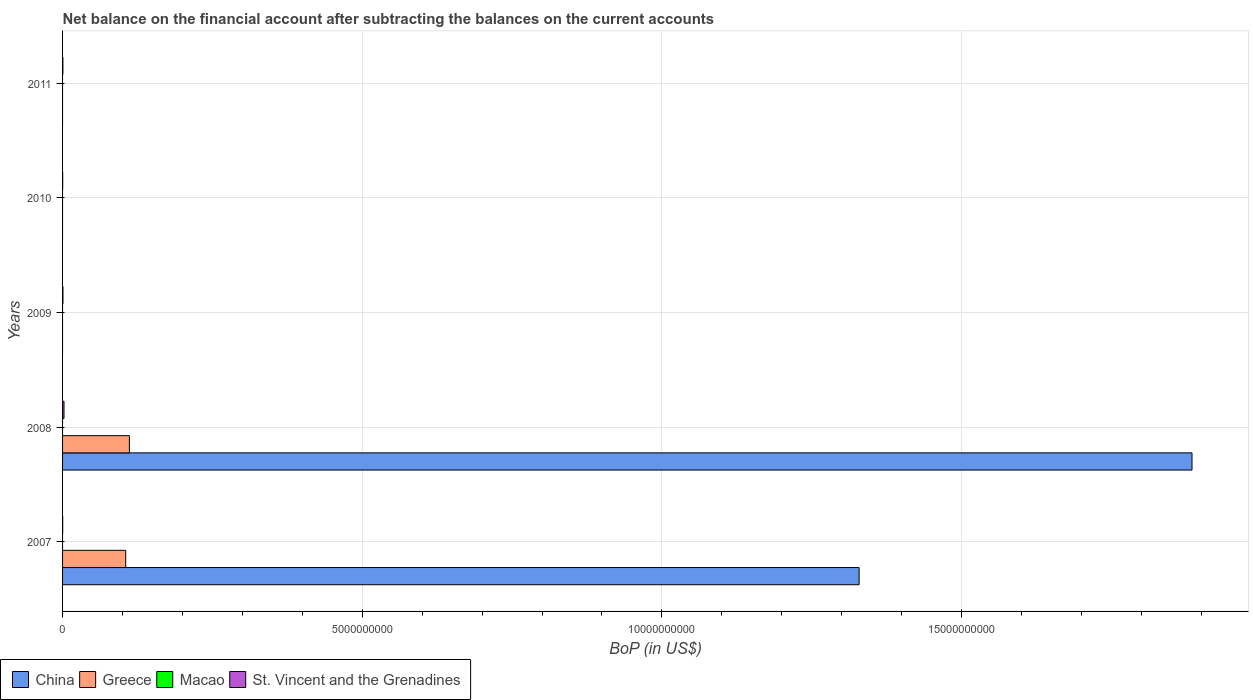Are the number of bars per tick equal to the number of legend labels?
Give a very brief answer. No. How many bars are there on the 1st tick from the bottom?
Ensure brevity in your answer.  3. In how many cases, is the number of bars for a given year not equal to the number of legend labels?
Provide a short and direct response. 5. Across all years, what is the maximum Balance of Payments in Greece?
Provide a short and direct response. 1.12e+09. Across all years, what is the minimum Balance of Payments in Greece?
Ensure brevity in your answer.  0. What is the difference between the Balance of Payments in St. Vincent and the Grenadines in 2009 and that in 2011?
Make the answer very short. 1.20e+06. What is the average Balance of Payments in Macao per year?
Your response must be concise. 0. In the year 2008, what is the difference between the Balance of Payments in St. Vincent and the Grenadines and Balance of Payments in China?
Offer a very short reply. -1.88e+1. In how many years, is the Balance of Payments in China greater than 15000000000 US$?
Ensure brevity in your answer.  1. What is the ratio of the Balance of Payments in St. Vincent and the Grenadines in 2007 to that in 2010?
Your answer should be compact. 1.14. Is the difference between the Balance of Payments in St. Vincent and the Grenadines in 2007 and 2008 greater than the difference between the Balance of Payments in China in 2007 and 2008?
Offer a very short reply. Yes. What is the difference between the highest and the second highest Balance of Payments in St. Vincent and the Grenadines?
Your response must be concise. 1.78e+07. What is the difference between the highest and the lowest Balance of Payments in China?
Offer a very short reply. 1.88e+1. Is it the case that in every year, the sum of the Balance of Payments in Greece and Balance of Payments in Macao is greater than the Balance of Payments in St. Vincent and the Grenadines?
Keep it short and to the point. No. Does the graph contain any zero values?
Your answer should be very brief. Yes. How many legend labels are there?
Ensure brevity in your answer.  4. How are the legend labels stacked?
Offer a terse response. Horizontal. What is the title of the graph?
Provide a succinct answer. Net balance on the financial account after subtracting the balances on the current accounts. Does "Middle East & North Africa (all income levels)" appear as one of the legend labels in the graph?
Ensure brevity in your answer.  No. What is the label or title of the X-axis?
Provide a succinct answer. BoP (in US$). What is the label or title of the Y-axis?
Offer a very short reply. Years. What is the BoP (in US$) in China in 2007?
Provide a short and direct response. 1.33e+1. What is the BoP (in US$) in Greece in 2007?
Your response must be concise. 1.05e+09. What is the BoP (in US$) in Macao in 2007?
Your answer should be compact. 0. What is the BoP (in US$) of St. Vincent and the Grenadines in 2007?
Provide a succinct answer. 2.05e+06. What is the BoP (in US$) in China in 2008?
Your response must be concise. 1.88e+1. What is the BoP (in US$) in Greece in 2008?
Offer a very short reply. 1.12e+09. What is the BoP (in US$) of Macao in 2008?
Provide a short and direct response. 0. What is the BoP (in US$) in St. Vincent and the Grenadines in 2008?
Provide a short and direct response. 2.42e+07. What is the BoP (in US$) of St. Vincent and the Grenadines in 2009?
Ensure brevity in your answer.  6.35e+06. What is the BoP (in US$) of Macao in 2010?
Make the answer very short. 0. What is the BoP (in US$) of St. Vincent and the Grenadines in 2010?
Provide a succinct answer. 1.79e+06. What is the BoP (in US$) of Greece in 2011?
Keep it short and to the point. 0. What is the BoP (in US$) in Macao in 2011?
Your answer should be very brief. 0. What is the BoP (in US$) in St. Vincent and the Grenadines in 2011?
Your answer should be compact. 5.15e+06. Across all years, what is the maximum BoP (in US$) of China?
Your response must be concise. 1.88e+1. Across all years, what is the maximum BoP (in US$) in Greece?
Offer a terse response. 1.12e+09. Across all years, what is the maximum BoP (in US$) in St. Vincent and the Grenadines?
Your response must be concise. 2.42e+07. Across all years, what is the minimum BoP (in US$) in China?
Your answer should be very brief. 0. Across all years, what is the minimum BoP (in US$) in Greece?
Offer a very short reply. 0. Across all years, what is the minimum BoP (in US$) in St. Vincent and the Grenadines?
Your answer should be compact. 1.79e+06. What is the total BoP (in US$) in China in the graph?
Offer a very short reply. 3.21e+1. What is the total BoP (in US$) of Greece in the graph?
Your answer should be very brief. 2.17e+09. What is the total BoP (in US$) in Macao in the graph?
Provide a short and direct response. 0. What is the total BoP (in US$) of St. Vincent and the Grenadines in the graph?
Make the answer very short. 3.95e+07. What is the difference between the BoP (in US$) of China in 2007 and that in 2008?
Your answer should be very brief. -5.55e+09. What is the difference between the BoP (in US$) in Greece in 2007 and that in 2008?
Your answer should be compact. -6.17e+07. What is the difference between the BoP (in US$) in St. Vincent and the Grenadines in 2007 and that in 2008?
Keep it short and to the point. -2.21e+07. What is the difference between the BoP (in US$) in St. Vincent and the Grenadines in 2007 and that in 2009?
Your answer should be compact. -4.30e+06. What is the difference between the BoP (in US$) of St. Vincent and the Grenadines in 2007 and that in 2010?
Offer a terse response. 2.57e+05. What is the difference between the BoP (in US$) of St. Vincent and the Grenadines in 2007 and that in 2011?
Offer a terse response. -3.10e+06. What is the difference between the BoP (in US$) in St. Vincent and the Grenadines in 2008 and that in 2009?
Offer a very short reply. 1.78e+07. What is the difference between the BoP (in US$) of St. Vincent and the Grenadines in 2008 and that in 2010?
Your answer should be very brief. 2.24e+07. What is the difference between the BoP (in US$) in St. Vincent and the Grenadines in 2008 and that in 2011?
Your answer should be very brief. 1.90e+07. What is the difference between the BoP (in US$) of St. Vincent and the Grenadines in 2009 and that in 2010?
Your answer should be compact. 4.56e+06. What is the difference between the BoP (in US$) of St. Vincent and the Grenadines in 2009 and that in 2011?
Offer a very short reply. 1.20e+06. What is the difference between the BoP (in US$) of St. Vincent and the Grenadines in 2010 and that in 2011?
Make the answer very short. -3.36e+06. What is the difference between the BoP (in US$) in China in 2007 and the BoP (in US$) in Greece in 2008?
Provide a short and direct response. 1.22e+1. What is the difference between the BoP (in US$) in China in 2007 and the BoP (in US$) in St. Vincent and the Grenadines in 2008?
Provide a succinct answer. 1.33e+1. What is the difference between the BoP (in US$) in Greece in 2007 and the BoP (in US$) in St. Vincent and the Grenadines in 2008?
Make the answer very short. 1.03e+09. What is the difference between the BoP (in US$) in China in 2007 and the BoP (in US$) in St. Vincent and the Grenadines in 2009?
Offer a terse response. 1.33e+1. What is the difference between the BoP (in US$) of Greece in 2007 and the BoP (in US$) of St. Vincent and the Grenadines in 2009?
Make the answer very short. 1.05e+09. What is the difference between the BoP (in US$) of China in 2007 and the BoP (in US$) of St. Vincent and the Grenadines in 2010?
Make the answer very short. 1.33e+1. What is the difference between the BoP (in US$) of Greece in 2007 and the BoP (in US$) of St. Vincent and the Grenadines in 2010?
Make the answer very short. 1.05e+09. What is the difference between the BoP (in US$) in China in 2007 and the BoP (in US$) in St. Vincent and the Grenadines in 2011?
Offer a very short reply. 1.33e+1. What is the difference between the BoP (in US$) of Greece in 2007 and the BoP (in US$) of St. Vincent and the Grenadines in 2011?
Your answer should be very brief. 1.05e+09. What is the difference between the BoP (in US$) in China in 2008 and the BoP (in US$) in St. Vincent and the Grenadines in 2009?
Offer a terse response. 1.88e+1. What is the difference between the BoP (in US$) of Greece in 2008 and the BoP (in US$) of St. Vincent and the Grenadines in 2009?
Offer a very short reply. 1.11e+09. What is the difference between the BoP (in US$) of China in 2008 and the BoP (in US$) of St. Vincent and the Grenadines in 2010?
Your answer should be very brief. 1.88e+1. What is the difference between the BoP (in US$) in Greece in 2008 and the BoP (in US$) in St. Vincent and the Grenadines in 2010?
Your answer should be very brief. 1.11e+09. What is the difference between the BoP (in US$) in China in 2008 and the BoP (in US$) in St. Vincent and the Grenadines in 2011?
Ensure brevity in your answer.  1.88e+1. What is the difference between the BoP (in US$) of Greece in 2008 and the BoP (in US$) of St. Vincent and the Grenadines in 2011?
Make the answer very short. 1.11e+09. What is the average BoP (in US$) in China per year?
Provide a succinct answer. 6.43e+09. What is the average BoP (in US$) in Greece per year?
Offer a terse response. 4.34e+08. What is the average BoP (in US$) in Macao per year?
Make the answer very short. 0. What is the average BoP (in US$) of St. Vincent and the Grenadines per year?
Your response must be concise. 7.90e+06. In the year 2007, what is the difference between the BoP (in US$) of China and BoP (in US$) of Greece?
Offer a terse response. 1.22e+1. In the year 2007, what is the difference between the BoP (in US$) in China and BoP (in US$) in St. Vincent and the Grenadines?
Your response must be concise. 1.33e+1. In the year 2007, what is the difference between the BoP (in US$) of Greece and BoP (in US$) of St. Vincent and the Grenadines?
Your answer should be compact. 1.05e+09. In the year 2008, what is the difference between the BoP (in US$) of China and BoP (in US$) of Greece?
Provide a short and direct response. 1.77e+1. In the year 2008, what is the difference between the BoP (in US$) of China and BoP (in US$) of St. Vincent and the Grenadines?
Keep it short and to the point. 1.88e+1. In the year 2008, what is the difference between the BoP (in US$) in Greece and BoP (in US$) in St. Vincent and the Grenadines?
Your response must be concise. 1.09e+09. What is the ratio of the BoP (in US$) in China in 2007 to that in 2008?
Offer a very short reply. 0.71. What is the ratio of the BoP (in US$) in Greece in 2007 to that in 2008?
Provide a short and direct response. 0.94. What is the ratio of the BoP (in US$) in St. Vincent and the Grenadines in 2007 to that in 2008?
Your response must be concise. 0.08. What is the ratio of the BoP (in US$) of St. Vincent and the Grenadines in 2007 to that in 2009?
Your answer should be compact. 0.32. What is the ratio of the BoP (in US$) in St. Vincent and the Grenadines in 2007 to that in 2010?
Give a very brief answer. 1.14. What is the ratio of the BoP (in US$) of St. Vincent and the Grenadines in 2007 to that in 2011?
Give a very brief answer. 0.4. What is the ratio of the BoP (in US$) in St. Vincent and the Grenadines in 2008 to that in 2009?
Make the answer very short. 3.81. What is the ratio of the BoP (in US$) in St. Vincent and the Grenadines in 2008 to that in 2010?
Provide a succinct answer. 13.51. What is the ratio of the BoP (in US$) in St. Vincent and the Grenadines in 2008 to that in 2011?
Your answer should be compact. 4.7. What is the ratio of the BoP (in US$) in St. Vincent and the Grenadines in 2009 to that in 2010?
Keep it short and to the point. 3.55. What is the ratio of the BoP (in US$) of St. Vincent and the Grenadines in 2009 to that in 2011?
Give a very brief answer. 1.23. What is the ratio of the BoP (in US$) in St. Vincent and the Grenadines in 2010 to that in 2011?
Offer a terse response. 0.35. What is the difference between the highest and the second highest BoP (in US$) of St. Vincent and the Grenadines?
Give a very brief answer. 1.78e+07. What is the difference between the highest and the lowest BoP (in US$) of China?
Offer a terse response. 1.88e+1. What is the difference between the highest and the lowest BoP (in US$) in Greece?
Your answer should be compact. 1.12e+09. What is the difference between the highest and the lowest BoP (in US$) in St. Vincent and the Grenadines?
Ensure brevity in your answer.  2.24e+07. 